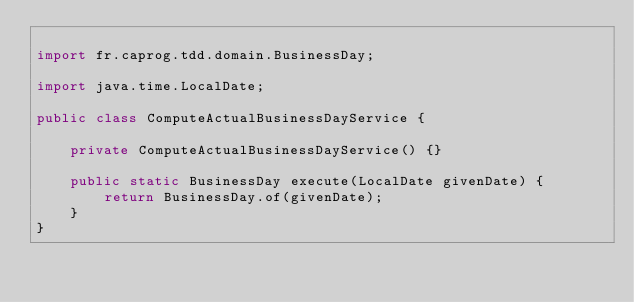<code> <loc_0><loc_0><loc_500><loc_500><_Java_>
import fr.caprog.tdd.domain.BusinessDay;

import java.time.LocalDate;

public class ComputeActualBusinessDayService {

    private ComputeActualBusinessDayService() {}

    public static BusinessDay execute(LocalDate givenDate) {
        return BusinessDay.of(givenDate);
    }
}
</code> 